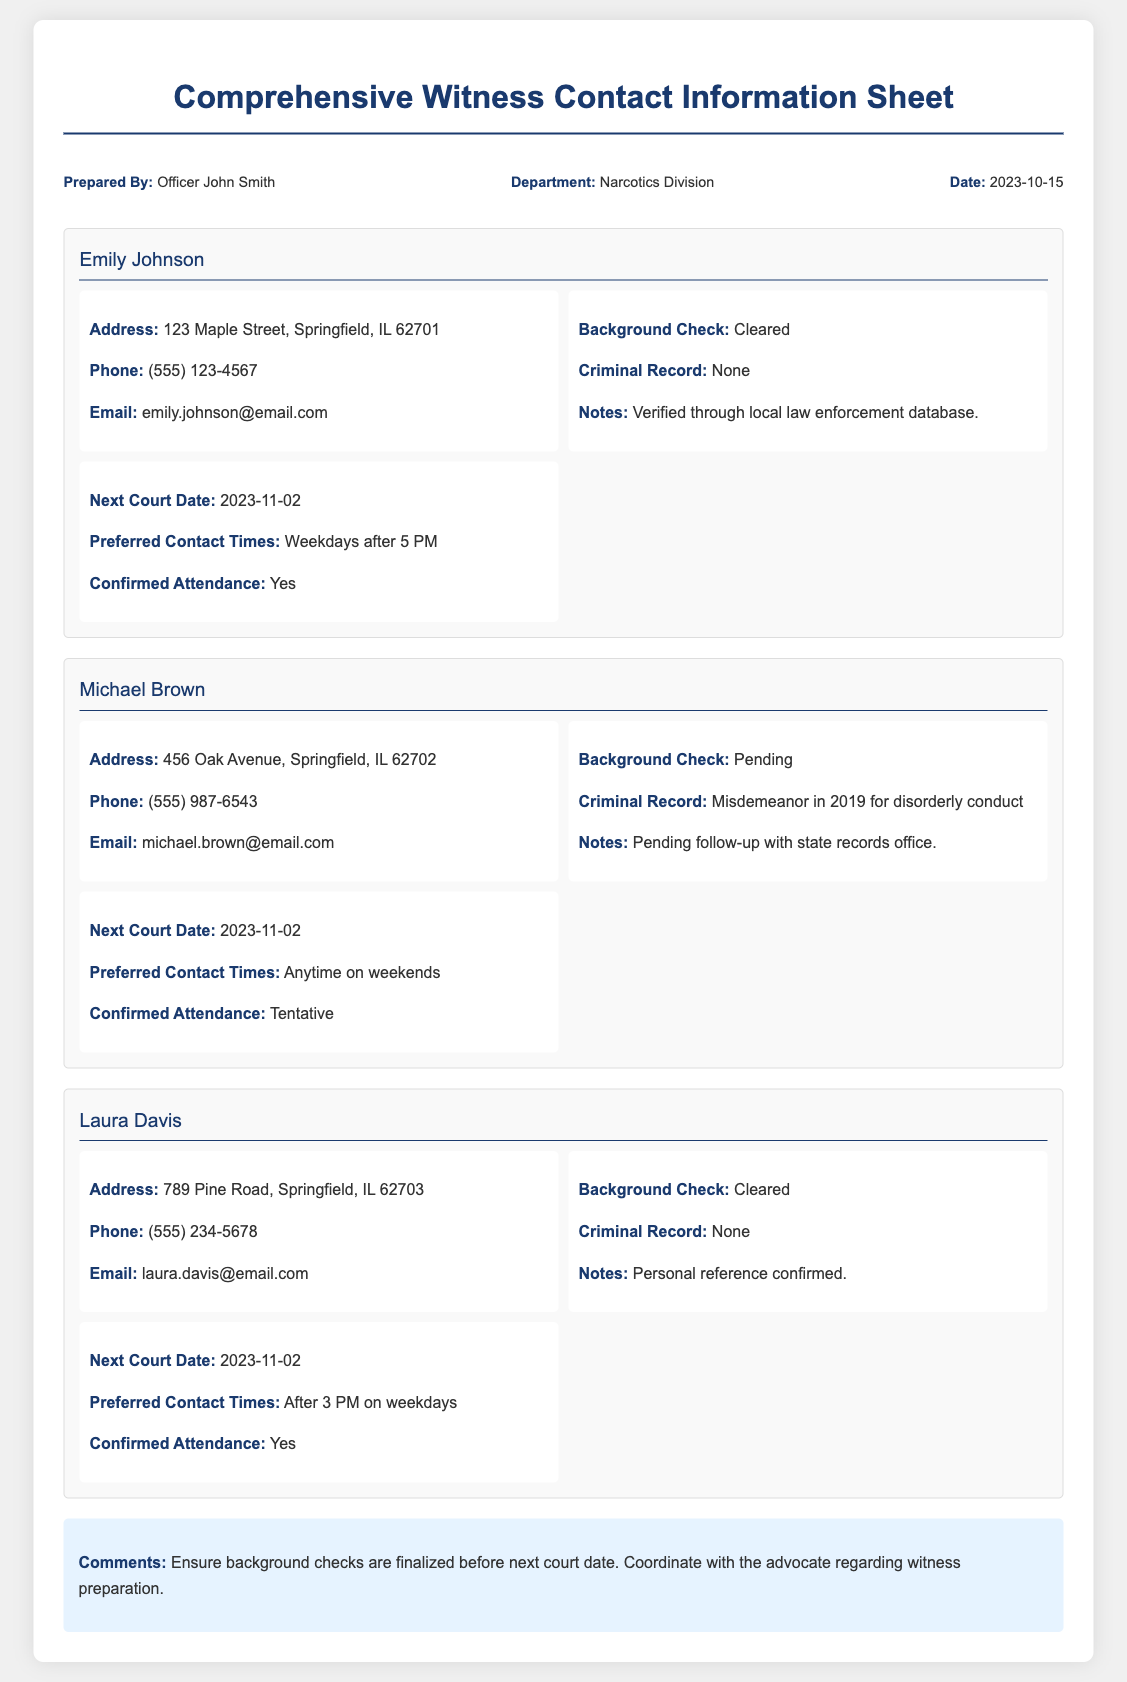what is the name of the prepared by officer? The document specifies that it was prepared by Officer John Smith.
Answer: Officer John Smith what is the next court date for all witnesses? The document indicates that all witnesses are scheduled for the same next court date.
Answer: 2023-11-02 how many witnesses are listed in the document? The document presents three witnesses, each with distinct details.
Answer: 3 what is Emily Johnson's email address? Emily Johnson's contact information includes her email address found in the document.
Answer: emily.johnson@email.com what is Michael Brown's criminal record? The document provides information about Michael Brown's criminal history which includes a specific incident.
Answer: Misdemeanor in 2019 for disorderly conduct who confirmed Laura Davis's background check? The notes section for Laura Davis indicates how her background check was verified.
Answer: Personal reference confirmed what are the preferred contact times for Emily Johnson? The document specifies the preferred contact times for Emily Johnson.
Answer: Weekdays after 5 PM what is the background check status for Michael Brown? The document indicates that Michael Brown's background check is not yet completed.
Answer: Pending what comments are noted at the end of the document? The comments section outlines specific instructions regarding the witnesses' background checks and coordination.
Answer: Ensure background checks are finalized before next court date. Coordinate with the advocate regarding witness preparation 